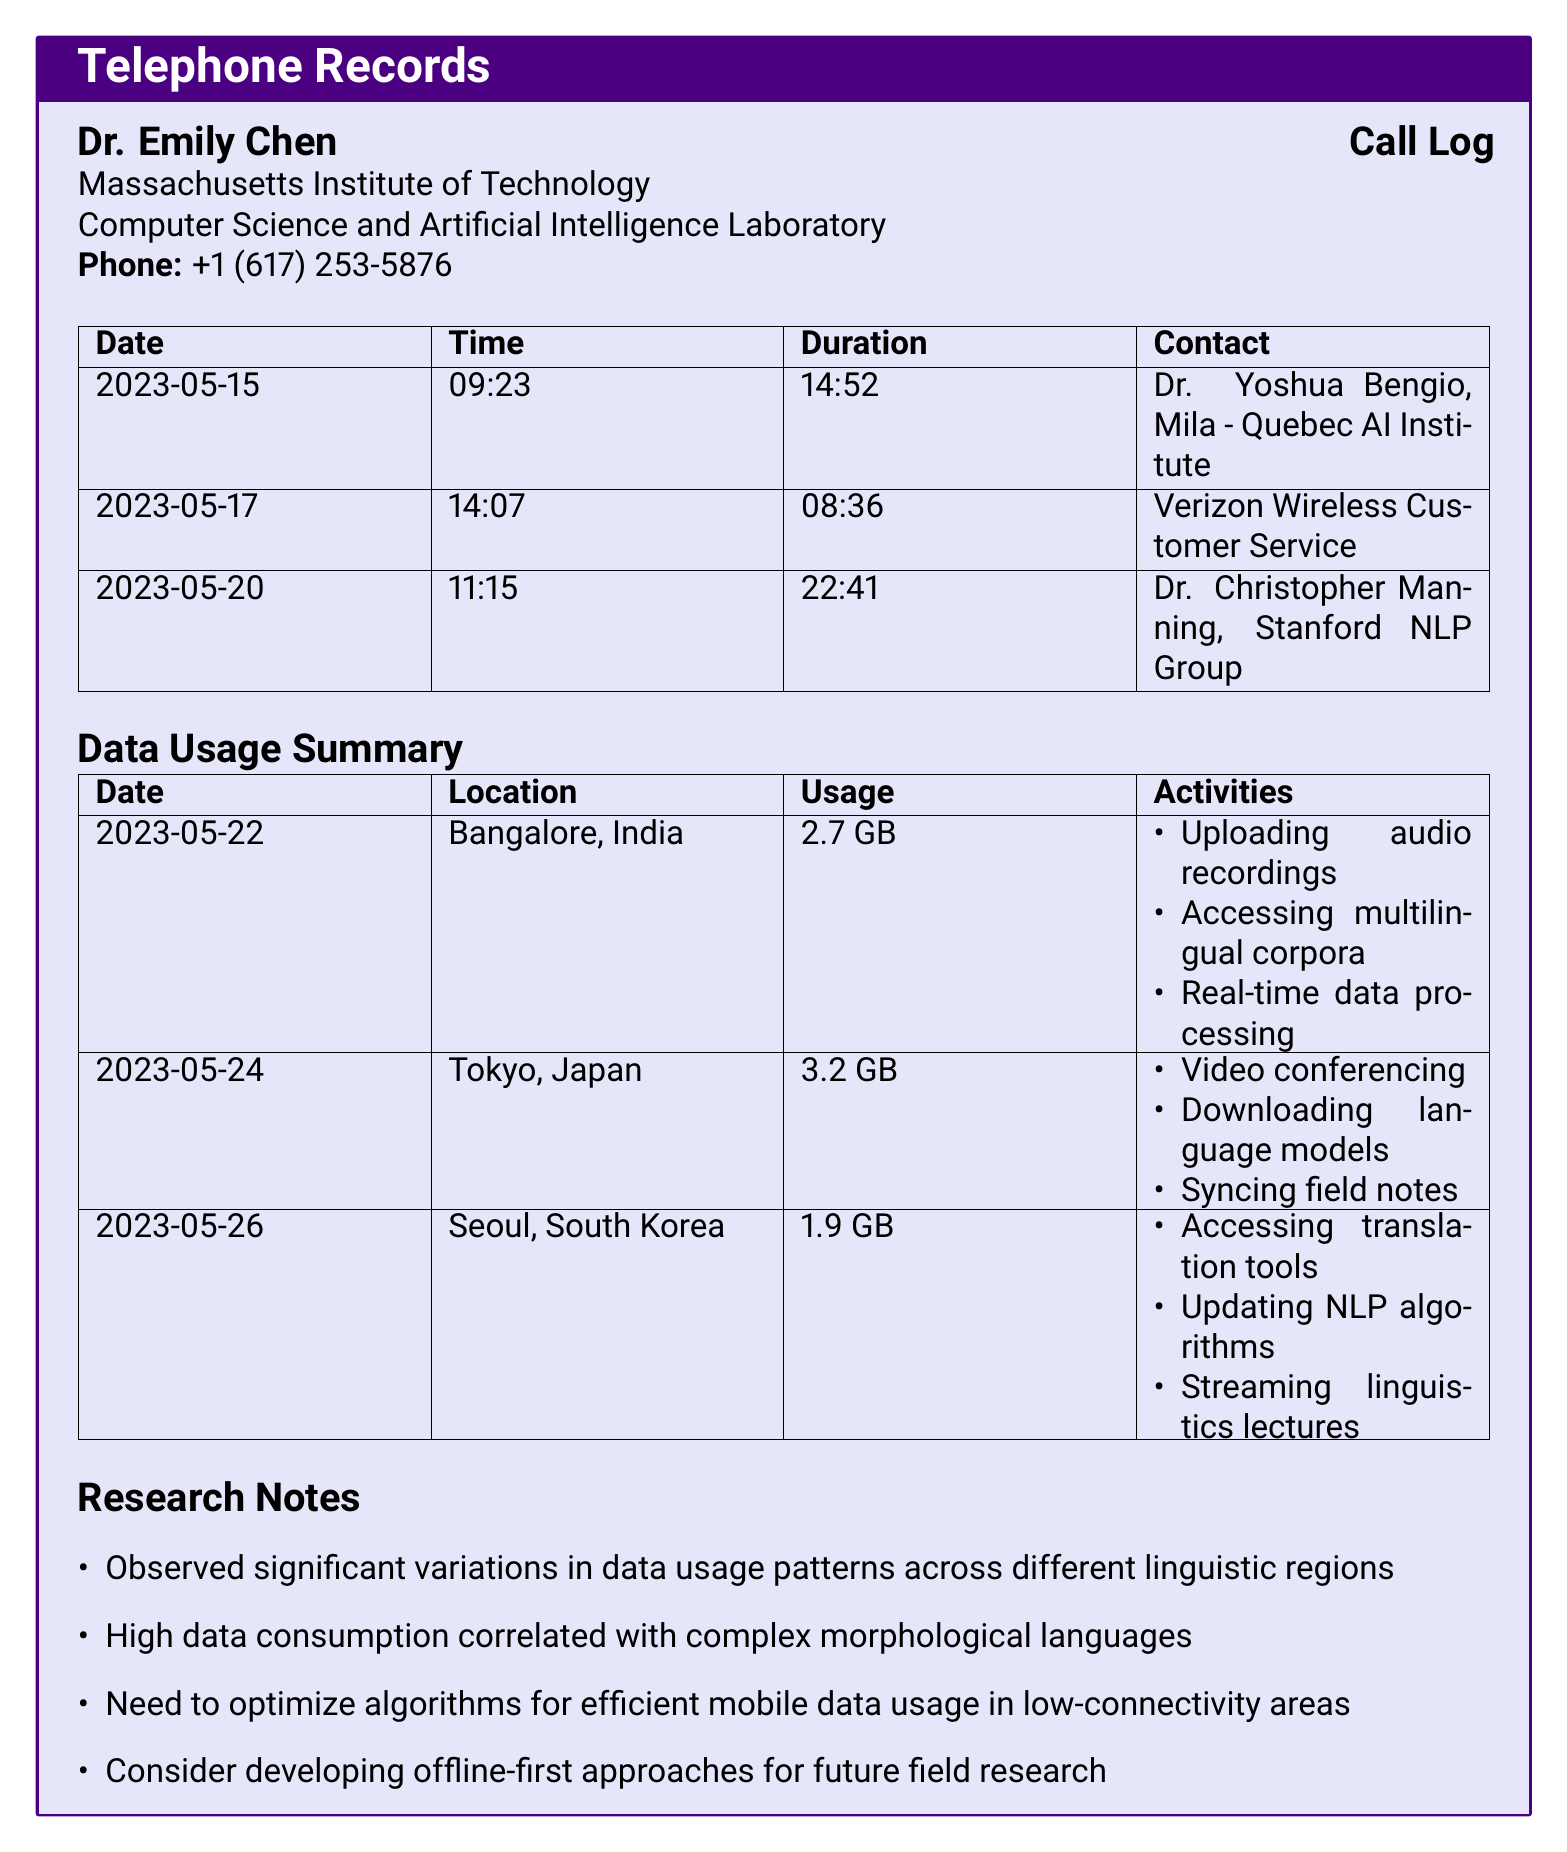What is the phone number of Dr. Emily Chen? The phone number is provided in the document under her contact details.
Answer: +1 (617) 253-5876 What is the usage in Tokyo, Japan? The usage is specified in the data usage summary table for the mentioned date and location.
Answer: 3.2 GB Which research note indicates the need for optimization? The document includes a specific note referring to the need to optimize algorithms for a particular situation.
Answer: Need to optimize algorithms for efficient mobile data usage in low-connectivity areas Who did Dr. Emily Chen talk to on May 20? The call log lists the contact for that specific date.
Answer: Dr. Christopher Manning, Stanford NLP Group What activity is associated with the data usage in Bangalore, India? The document lists specific activities associated with the data usage for that location.
Answer: Uploading audio recordings How long was the call to Verizon Wireless Customer Service? The duration of that specific call is mentioned in the call log.
Answer: 08:36 What is observed regarding data consumption in complex languages? The research notes include observations about the correlation between data consumption and linguistic complexity.
Answer: High data consumption correlated with complex morphological languages 